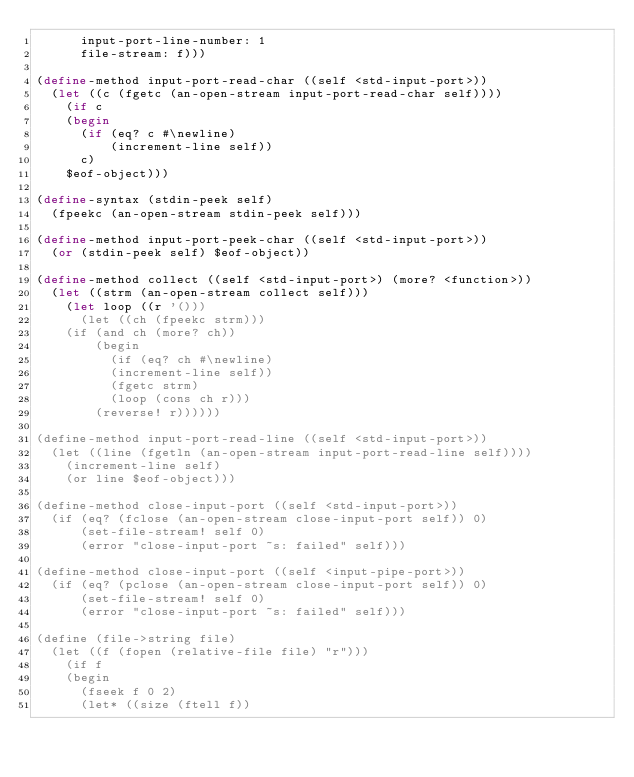Convert code to text. <code><loc_0><loc_0><loc_500><loc_500><_Scheme_>	  input-port-line-number: 1
	  file-stream: f)))

(define-method input-port-read-char ((self <std-input-port>))
  (let ((c (fgetc (an-open-stream input-port-read-char self))))
    (if c
	(begin
	  (if (eq? c #\newline)
	      (increment-line self))
	  c)
	$eof-object)))

(define-syntax (stdin-peek self)
  (fpeekc (an-open-stream stdin-peek self)))

(define-method input-port-peek-char ((self <std-input-port>))
  (or (stdin-peek self) $eof-object))

(define-method collect ((self <std-input-port>) (more? <function>))
  (let ((strm (an-open-stream collect self)))
    (let loop ((r '()))
      (let ((ch (fpeekc strm)))
	(if (and ch (more? ch))
	    (begin
	      (if (eq? ch #\newline)
		  (increment-line self))
	      (fgetc strm)
	      (loop (cons ch r)))
	    (reverse! r))))))

(define-method input-port-read-line ((self <std-input-port>))
  (let ((line (fgetln (an-open-stream input-port-read-line self))))
    (increment-line self)
    (or line $eof-object)))
  
(define-method close-input-port ((self <std-input-port>))
  (if (eq? (fclose (an-open-stream close-input-port self)) 0)
      (set-file-stream! self 0)
      (error "close-input-port ~s: failed" self)))

(define-method close-input-port ((self <input-pipe-port>))
  (if (eq? (pclose (an-open-stream close-input-port self)) 0)
      (set-file-stream! self 0)
      (error "close-input-port ~s: failed" self)))

(define (file->string file)
  (let ((f (fopen (relative-file file) "r")))
    (if f
	(begin
	  (fseek f 0 2)
	  (let* ((size (ftell f))</code> 